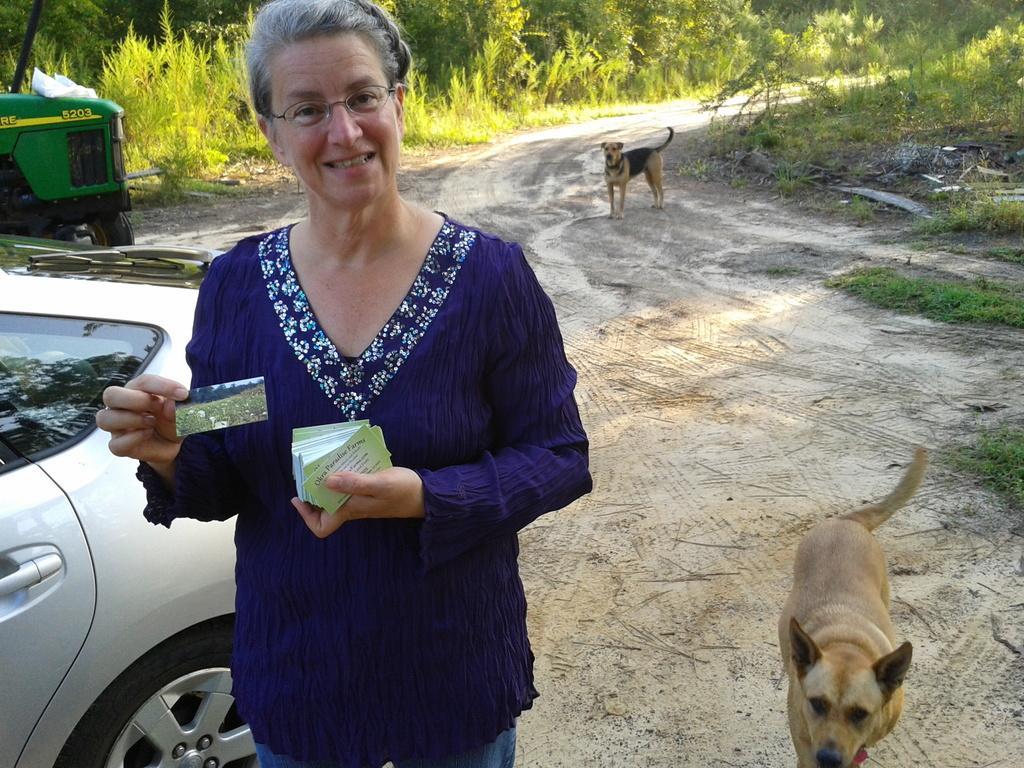Describe this image in one or two sentences. A woman is standing wearing a blue dress and holding cards. There are vehicles at the left. There are dogs and trees at the back. 